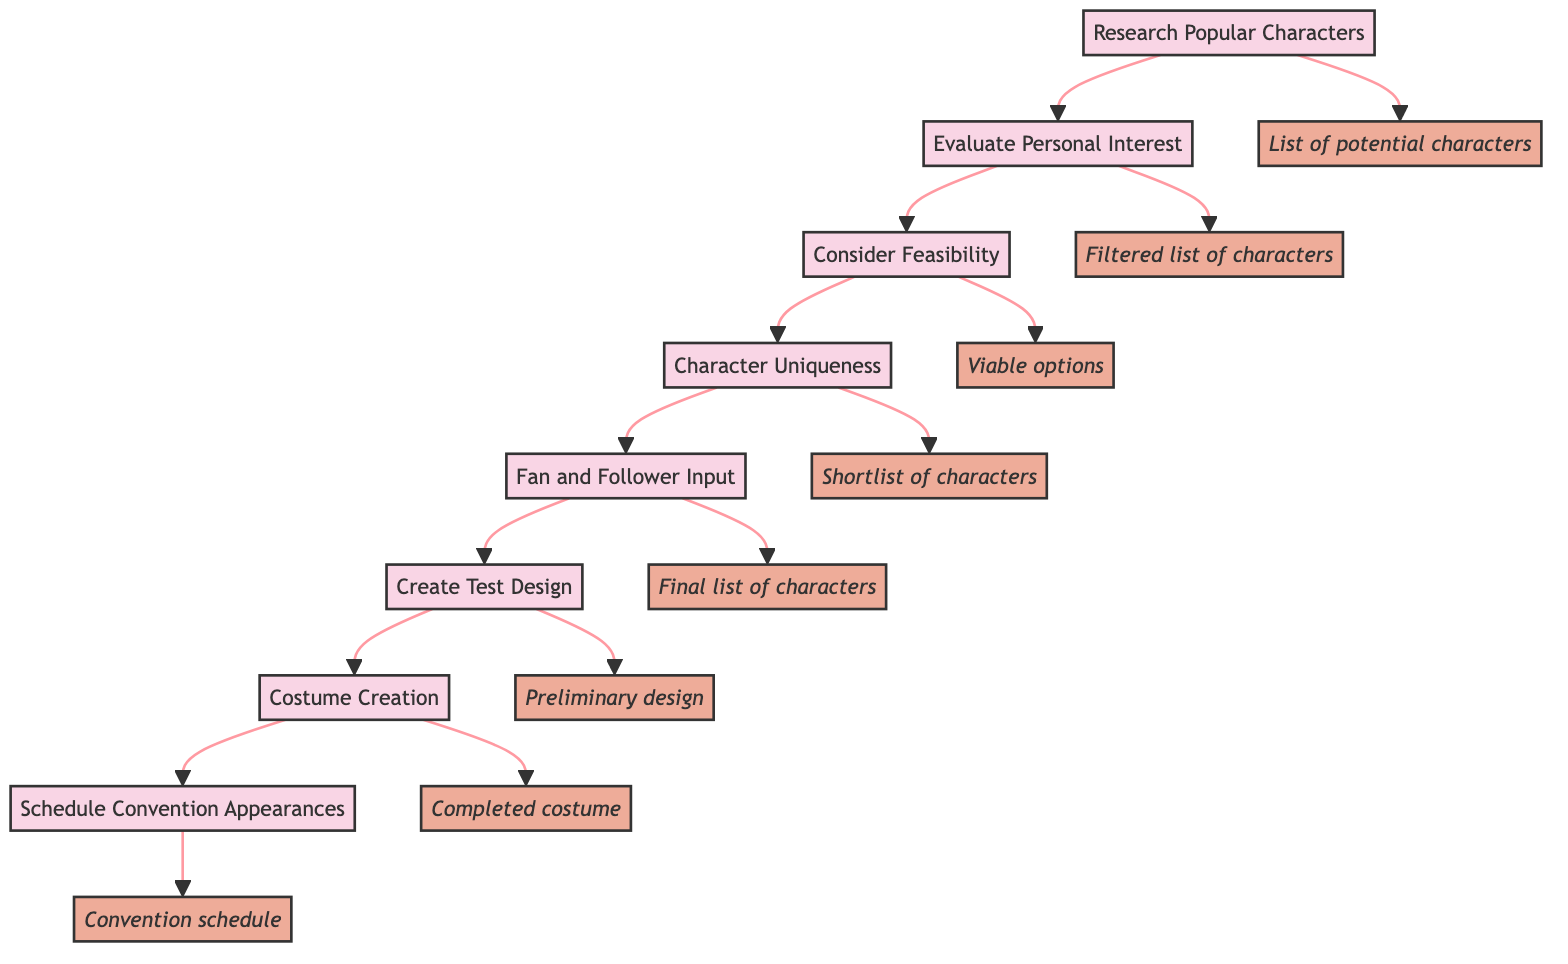What is the first step in the character selection process? The first step in the flow chart is "Research Popular Characters." This can be identified as it is the topmost node in the diagram.
Answer: Research Popular Characters How many total steps are in the character selection process? By counting the nodes in the flow chart, we can identify that there are a total of eight distinct steps from "Research Popular Characters" to "Schedule Convention Appearances."
Answer: 8 What is the outcome of the third step? The third step is "Consider Feasibility," and it leads to the outcome noted as "Viable options." This can be verified by locating the corresponding node linked to the third step.
Answer: Viable options Which step follows "Fan and Follower Input"? The step that follows "Fan and Follower Input" is "Create Test Design." This can be determined by following the arrow from the "Fan and Follower Input" node to the next node.
Answer: Create Test Design What is the last outcome listed in the diagram? The last outcome listed in the diagram corresponds to "Convention schedule," which is linked to the final step "Schedule Convention Appearances." This is the endpoint of the flow chart.
Answer: Convention schedule What step evaluates character uniqueness? The step that evaluates character uniqueness is "Character Uniqueness." This can be identified by its direct placement between "Consider Feasibility" and "Fan and Follower Input."
Answer: Character Uniqueness How does the creation of a costume begin? The creation of a costume begins with the step "Costume Creation," which follows the preliminary design stage and the sourcing of materials. This can be traced through the arrows leading to this node.
Answer: Costume Creation What is the relationship between "Evaluate Personal Interest" and "Filtered list of characters"? The relationship is that "Evaluate Personal Interest" is the step that produces the outcome "Filtered list of characters." This can be deduced from the direct link between the evaluation step and its corresponding outcome.
Answer: Outcome relationship 